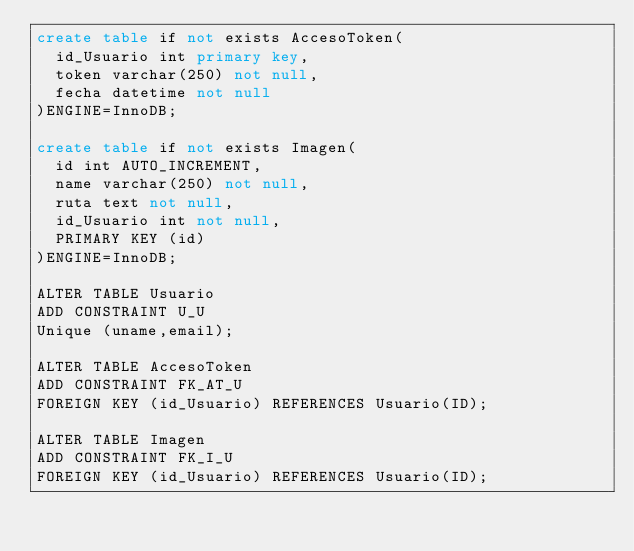Convert code to text. <code><loc_0><loc_0><loc_500><loc_500><_SQL_>create table if not exists AccesoToken(
	id_Usuario int primary key, 
	token varchar(250) not null,
	fecha datetime not null
)ENGINE=InnoDB;

create table if not exists Imagen(
	id int AUTO_INCREMENT, 
	name varchar(250) not null,
	ruta text not null,
	id_Usuario int not null,
	PRIMARY KEY (id)
)ENGINE=InnoDB;

ALTER TABLE Usuario
ADD CONSTRAINT U_U
Unique (uname,email); 

ALTER TABLE AccesoToken 
ADD CONSTRAINT FK_AT_U
FOREIGN KEY (id_Usuario) REFERENCES Usuario(ID); 

ALTER TABLE Imagen 
ADD CONSTRAINT FK_I_U
FOREIGN KEY (id_Usuario) REFERENCES Usuario(ID); 
</code> 